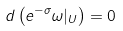Convert formula to latex. <formula><loc_0><loc_0><loc_500><loc_500>d \left ( e ^ { - \sigma } \omega | _ { U } \right ) = 0</formula> 